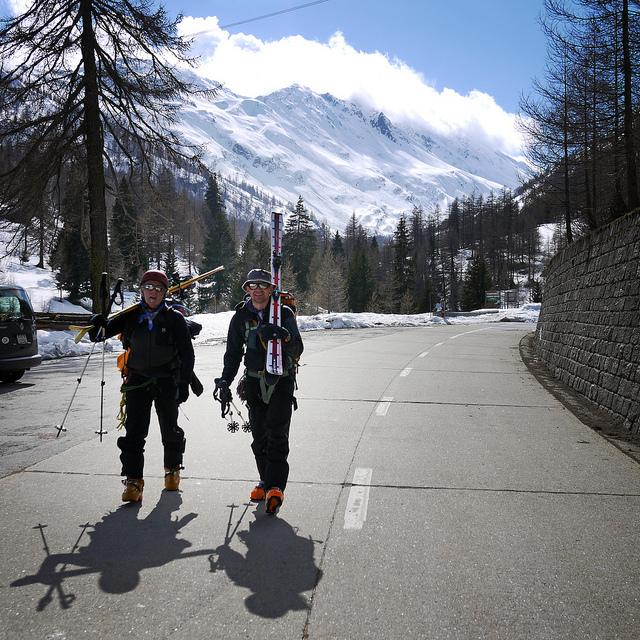The men here prefer to stop at which elevation to start their day of fun?

Choices:
A) here
B) lower
C) higher
D) same higher 